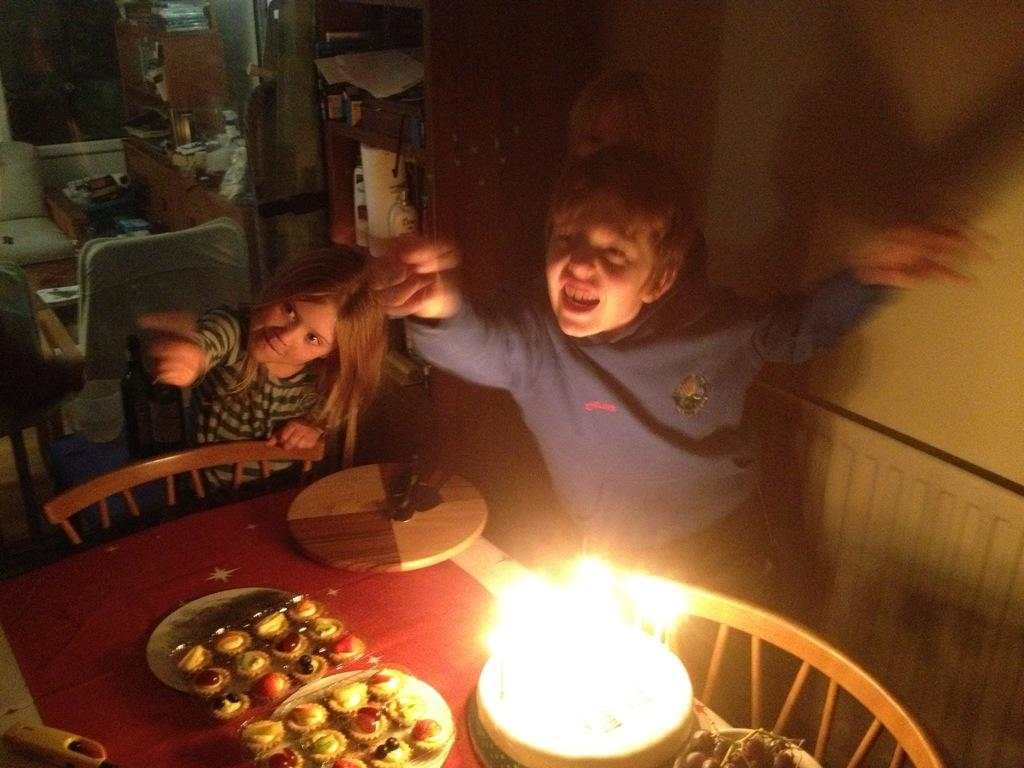How many people are present in the image? There is a girl and a boy in the image. What is on the table in the image? There is a cake and cookies on the table. What type of furniture is present in the image? There is a table and chairs in the image. What can be seen in the background of the image? There is a wall and a rack in the background of the image. What type of lock is used on the door in the image? There is no door or lock present in the image. What is the stranger doing in the image? There is no stranger present in the image. 